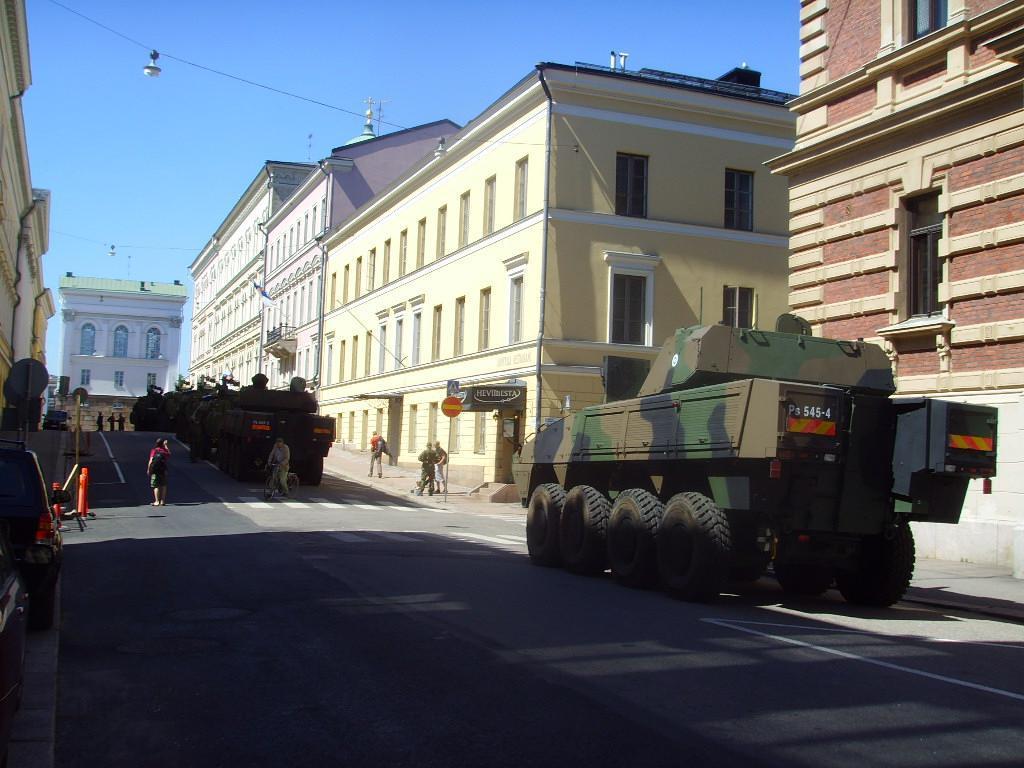Please provide a concise description of this image. This is an outside view. At the bottom there is a road and I can see few panzers and few people on the road. There are few people walking on the footpath. On the left side there are few cars. On both sides of the road there are many buildings. At the top of the image I can see the sky. 